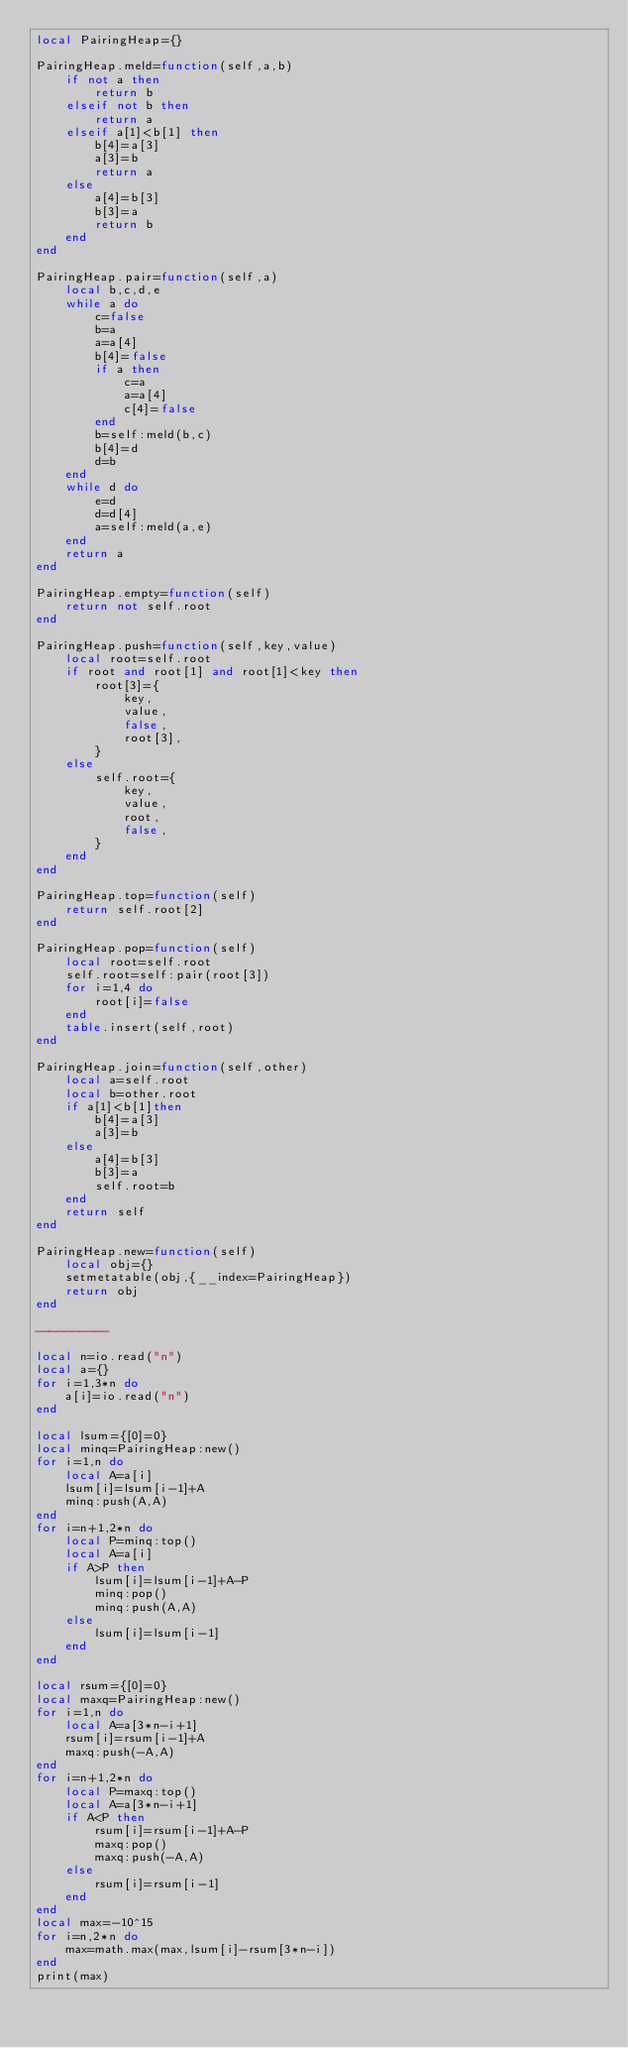Convert code to text. <code><loc_0><loc_0><loc_500><loc_500><_Lua_>local PairingHeap={}

PairingHeap.meld=function(self,a,b)
    if not a then
        return b
    elseif not b then
        return a
    elseif a[1]<b[1] then
        b[4]=a[3]
        a[3]=b
        return a
    else
        a[4]=b[3]
        b[3]=a
        return b
    end
end

PairingHeap.pair=function(self,a)
    local b,c,d,e
    while a do
        c=false
        b=a
        a=a[4]
        b[4]=false
        if a then
            c=a
            a=a[4]   
            c[4]=false
        end
        b=self:meld(b,c)
        b[4]=d
        d=b
    end
    while d do
        e=d
        d=d[4]
        a=self:meld(a,e)
    end
    return a
end

PairingHeap.empty=function(self)
    return not self.root
end

PairingHeap.push=function(self,key,value)
    local root=self.root
    if root and root[1] and root[1]<key then
        root[3]={
            key,
            value,
            false,
            root[3],
        }
    else
        self.root={
            key,
            value,
            root,
            false,
        }
    end
end

PairingHeap.top=function(self)
	return self.root[2]
end

PairingHeap.pop=function(self)
    local root=self.root
    self.root=self:pair(root[3])
    for i=1,4 do
        root[i]=false
    end
    table.insert(self,root)
end

PairingHeap.join=function(self,other)
    local a=self.root
    local b=other.root
    if a[1]<b[1]then
        b[4]=a[3]
        a[3]=b
    else
        a[4]=b[3]
        b[3]=a
        self.root=b
    end
    return self
end

PairingHeap.new=function(self)
    local obj={}
    setmetatable(obj,{__index=PairingHeap})
    return obj
end

----------

local n=io.read("n")
local a={}
for i=1,3*n do
    a[i]=io.read("n")
end

local lsum={[0]=0}
local minq=PairingHeap:new()
for i=1,n do
    local A=a[i]
    lsum[i]=lsum[i-1]+A
    minq:push(A,A)
end
for i=n+1,2*n do
    local P=minq:top()
    local A=a[i]
    if A>P then
        lsum[i]=lsum[i-1]+A-P
        minq:pop()
        minq:push(A,A)
    else
        lsum[i]=lsum[i-1]
    end
end

local rsum={[0]=0}
local maxq=PairingHeap:new()
for i=1,n do
    local A=a[3*n-i+1]
    rsum[i]=rsum[i-1]+A
    maxq:push(-A,A)
end
for i=n+1,2*n do
    local P=maxq:top()
    local A=a[3*n-i+1]
    if A<P then
        rsum[i]=rsum[i-1]+A-P
        maxq:pop()
        maxq:push(-A,A)
    else
        rsum[i]=rsum[i-1]
    end
end
local max=-10^15
for i=n,2*n do
    max=math.max(max,lsum[i]-rsum[3*n-i])
end
print(max)</code> 